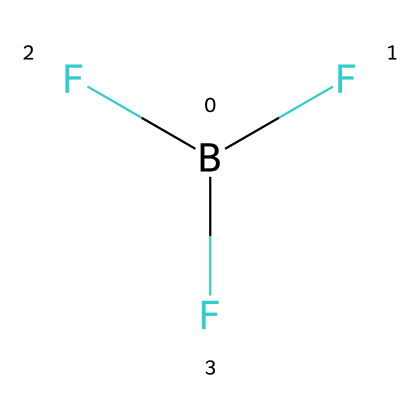What is the molecular formula of this chemical? The compound is boron trifluoride, which is represented by the formula B(F)(F)F. This indicates there is one boron atom and three fluorine atoms.
Answer: B(F)(F)F How many valence electrons does boron have in this structure? Boron is in group 13 of the periodic table, which means it has three valence electrons. This can be determined from its position in the periodic table.
Answer: 3 What is the hybridization of boron in boron trifluoride? In boron trifluoride, boron forms three sigma bonds with three fluorine atoms, leading to an sp2 hybridization. The trigonal planar arrangement suggests sp2 characteristics.
Answer: sp2 Which type of molecular geometry does boron trifluoride exhibit? Boron trifluoride has a trigonal planar molecular geometry due to the three fluorine atoms arranged around the central boron atom in a plane at 120-degree angles.
Answer: trigonal planar Is boron trifluoride a Lewis acid? Boron trifluoride is known to be a Lewis acid because it can accept a pair of electrons due to the electron deficiency of boron. This is a defining characteristic of Lewis acids.
Answer: yes What type of bond exists between boron and fluorine in this compound? The bonds between boron and fluorine are covalent bonds, specifically polar covalent, due to the high electronegativity difference between boron and fluorine.
Answer: covalent How many fluorine atoms surround the boron atom in this structure? The structure shows that boron is directly bonded to three fluorine atoms as indicated by the three F groups attached to the B atom.
Answer: 3 